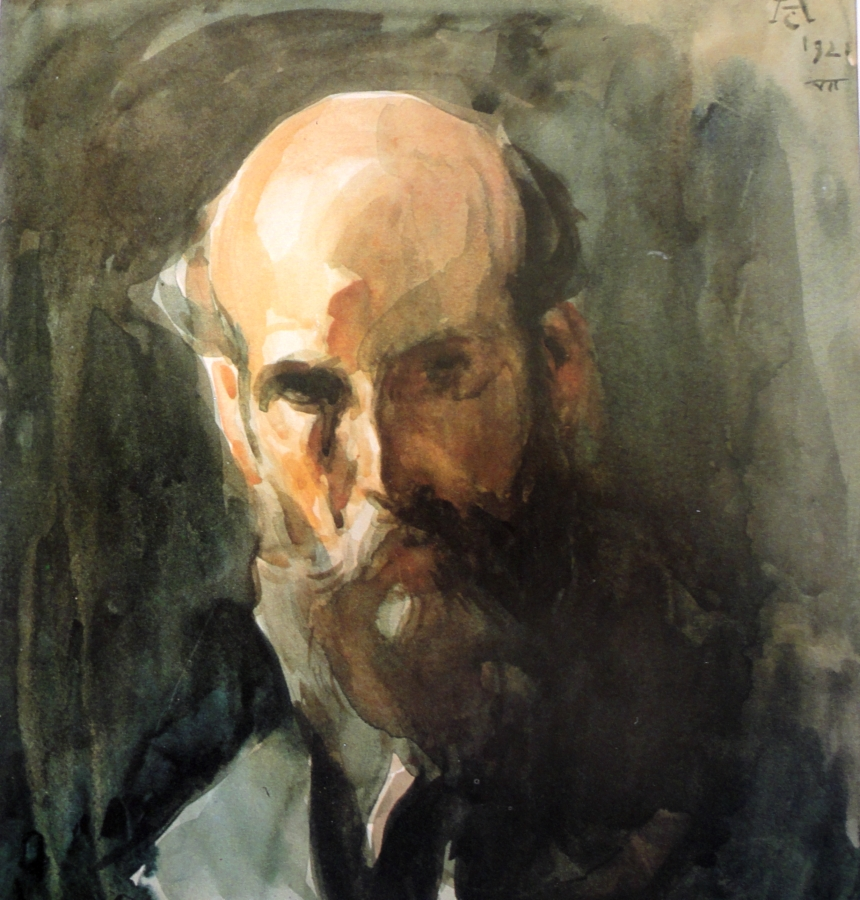Can you describe the technique used in this painting? The painting employs a watercolor technique, characterized by its fluid and translucent quality. The artist uses loose and expressive brushstrokes, creating an abstract and dynamic feel. The overlapping layers of earthy tones like browns and greens contribute to the depth and texture of the portrait. This technique allows the viewer to engage more deeply with the emotional undertone of the piece. 